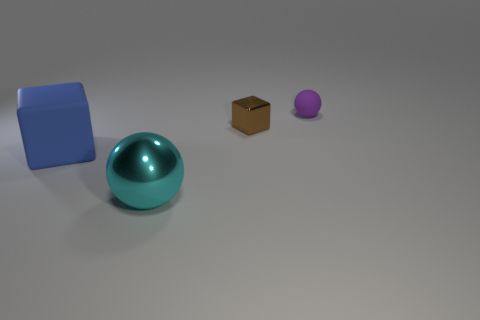There is a ball that is behind the cube on the right side of the big ball; how big is it?
Give a very brief answer. Small. What number of other objects are the same color as the small ball?
Ensure brevity in your answer.  0. What is the tiny brown block made of?
Your response must be concise. Metal. Is there a brown rubber cylinder?
Provide a short and direct response. No. Is the number of large cyan objects behind the brown metal object the same as the number of red blocks?
Your response must be concise. Yes. Is there anything else that is made of the same material as the brown thing?
Provide a short and direct response. Yes. What number of tiny objects are either cubes or matte cylinders?
Provide a short and direct response. 1. Are the ball behind the big cube and the blue object made of the same material?
Your answer should be very brief. Yes. There is a cube on the right side of the metallic thing in front of the small metal block; what is its material?
Make the answer very short. Metal. What number of brown objects have the same shape as the blue thing?
Provide a succinct answer. 1. 